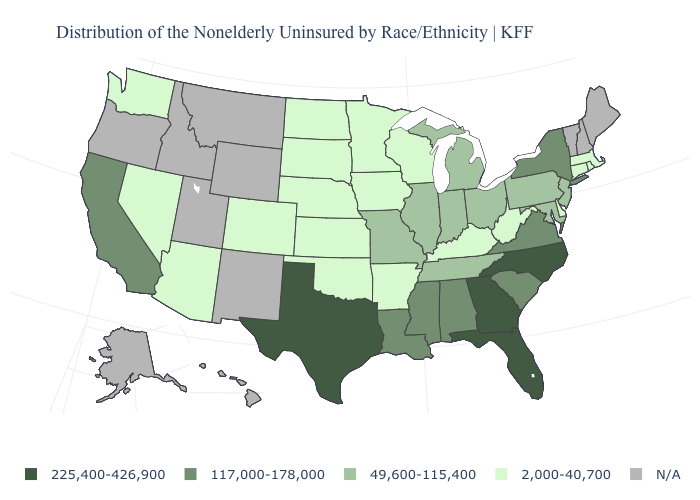What is the value of Oregon?
Concise answer only. N/A. Which states have the lowest value in the USA?
Quick response, please. Arizona, Arkansas, Colorado, Connecticut, Delaware, Iowa, Kansas, Kentucky, Massachusetts, Minnesota, Nebraska, Nevada, North Dakota, Oklahoma, Rhode Island, South Dakota, Washington, West Virginia, Wisconsin. What is the value of Virginia?
Quick response, please. 117,000-178,000. What is the value of Washington?
Concise answer only. 2,000-40,700. What is the highest value in the USA?
Quick response, please. 225,400-426,900. Name the states that have a value in the range 49,600-115,400?
Quick response, please. Illinois, Indiana, Maryland, Michigan, Missouri, New Jersey, Ohio, Pennsylvania, Tennessee. Does Arizona have the lowest value in the USA?
Be succinct. Yes. Name the states that have a value in the range 225,400-426,900?
Write a very short answer. Florida, Georgia, North Carolina, Texas. Among the states that border Nebraska , does Iowa have the lowest value?
Be succinct. Yes. Name the states that have a value in the range 225,400-426,900?
Keep it brief. Florida, Georgia, North Carolina, Texas. Does Pennsylvania have the highest value in the USA?
Short answer required. No. What is the lowest value in states that border Oregon?
Keep it brief. 2,000-40,700. Does California have the lowest value in the West?
Keep it brief. No. What is the lowest value in the USA?
Short answer required. 2,000-40,700. 